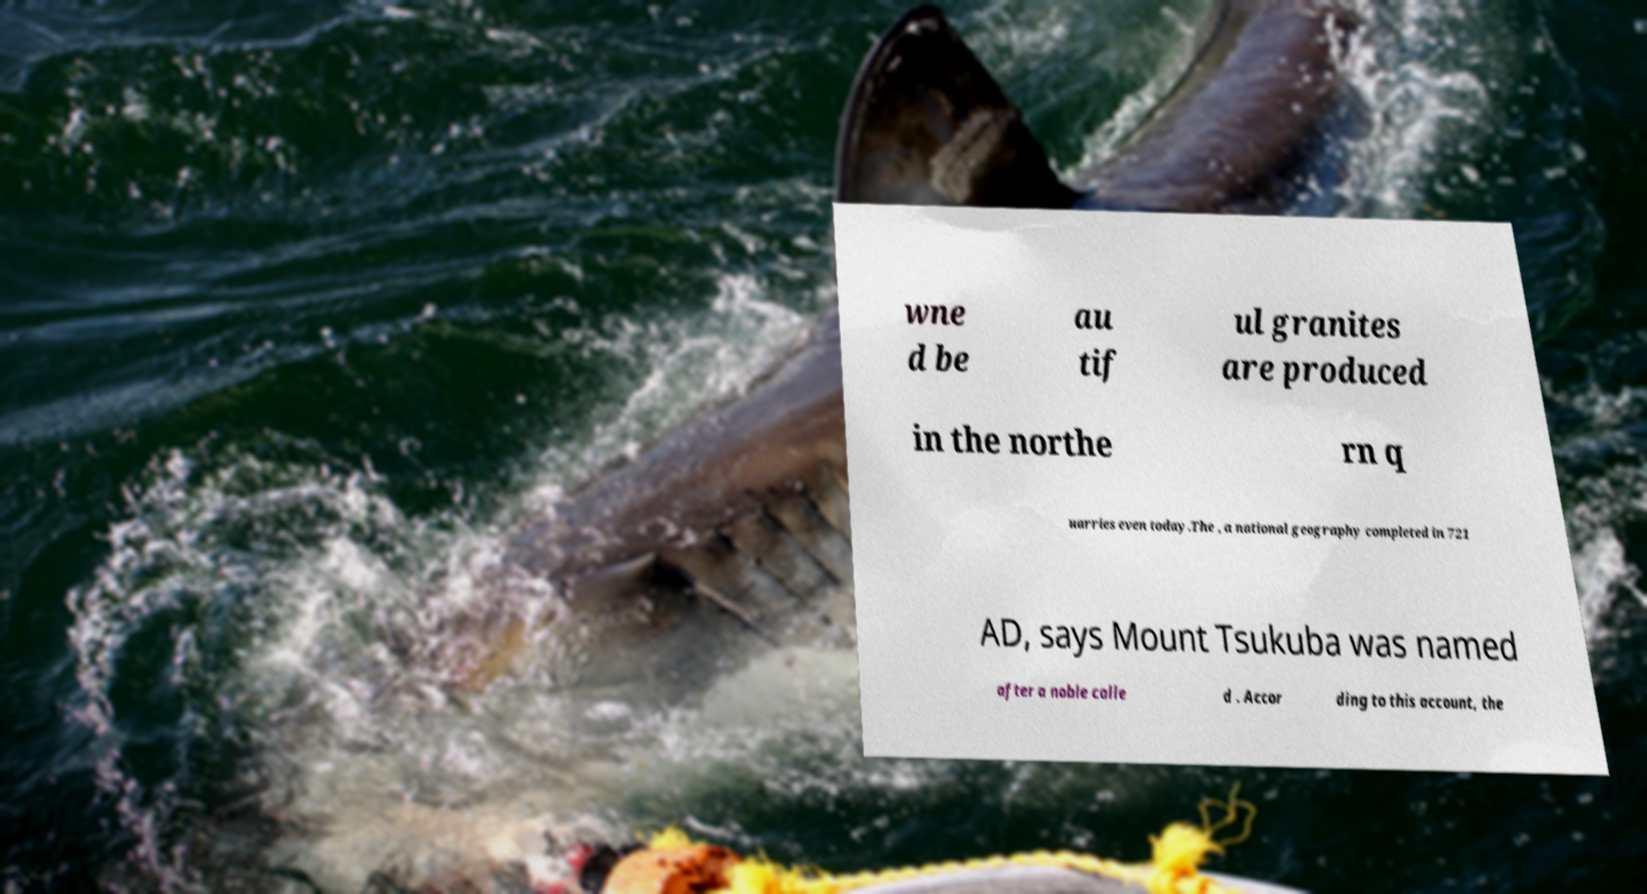Could you extract and type out the text from this image? wne d be au tif ul granites are produced in the northe rn q uarries even today.The , a national geography completed in 721 AD, says Mount Tsukuba was named after a noble calle d . Accor ding to this account, the 